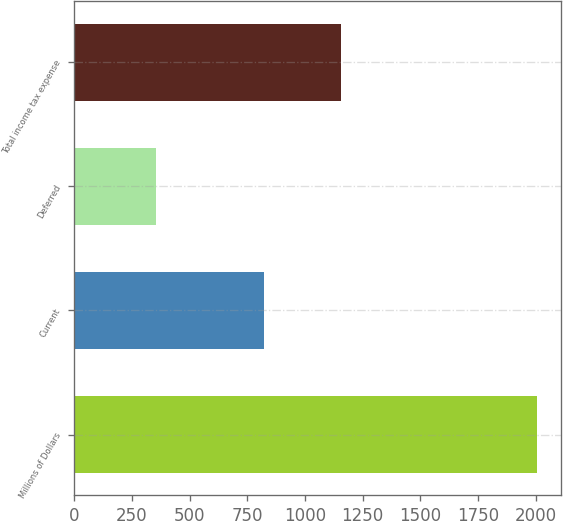<chart> <loc_0><loc_0><loc_500><loc_500><bar_chart><fcel>Millions of Dollars<fcel>Current<fcel>Deferred<fcel>Total income tax expense<nl><fcel>2007<fcel>822<fcel>354<fcel>1154<nl></chart> 